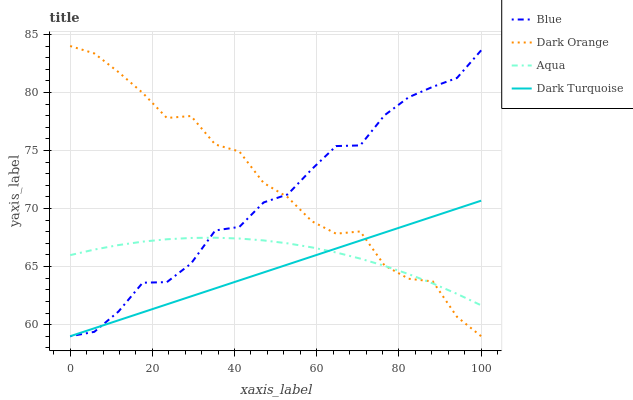Does Dark Turquoise have the minimum area under the curve?
Answer yes or no. Yes. Does Dark Orange have the maximum area under the curve?
Answer yes or no. Yes. Does Aqua have the minimum area under the curve?
Answer yes or no. No. Does Aqua have the maximum area under the curve?
Answer yes or no. No. Is Dark Turquoise the smoothest?
Answer yes or no. Yes. Is Dark Orange the roughest?
Answer yes or no. Yes. Is Aqua the smoothest?
Answer yes or no. No. Is Aqua the roughest?
Answer yes or no. No. Does Blue have the lowest value?
Answer yes or no. Yes. Does Aqua have the lowest value?
Answer yes or no. No. Does Dark Orange have the highest value?
Answer yes or no. Yes. Does Aqua have the highest value?
Answer yes or no. No. Does Dark Turquoise intersect Dark Orange?
Answer yes or no. Yes. Is Dark Turquoise less than Dark Orange?
Answer yes or no. No. Is Dark Turquoise greater than Dark Orange?
Answer yes or no. No. 